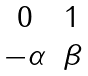<formula> <loc_0><loc_0><loc_500><loc_500>\begin{matrix} 0 & 1 \\ - \alpha & \beta \end{matrix}</formula> 